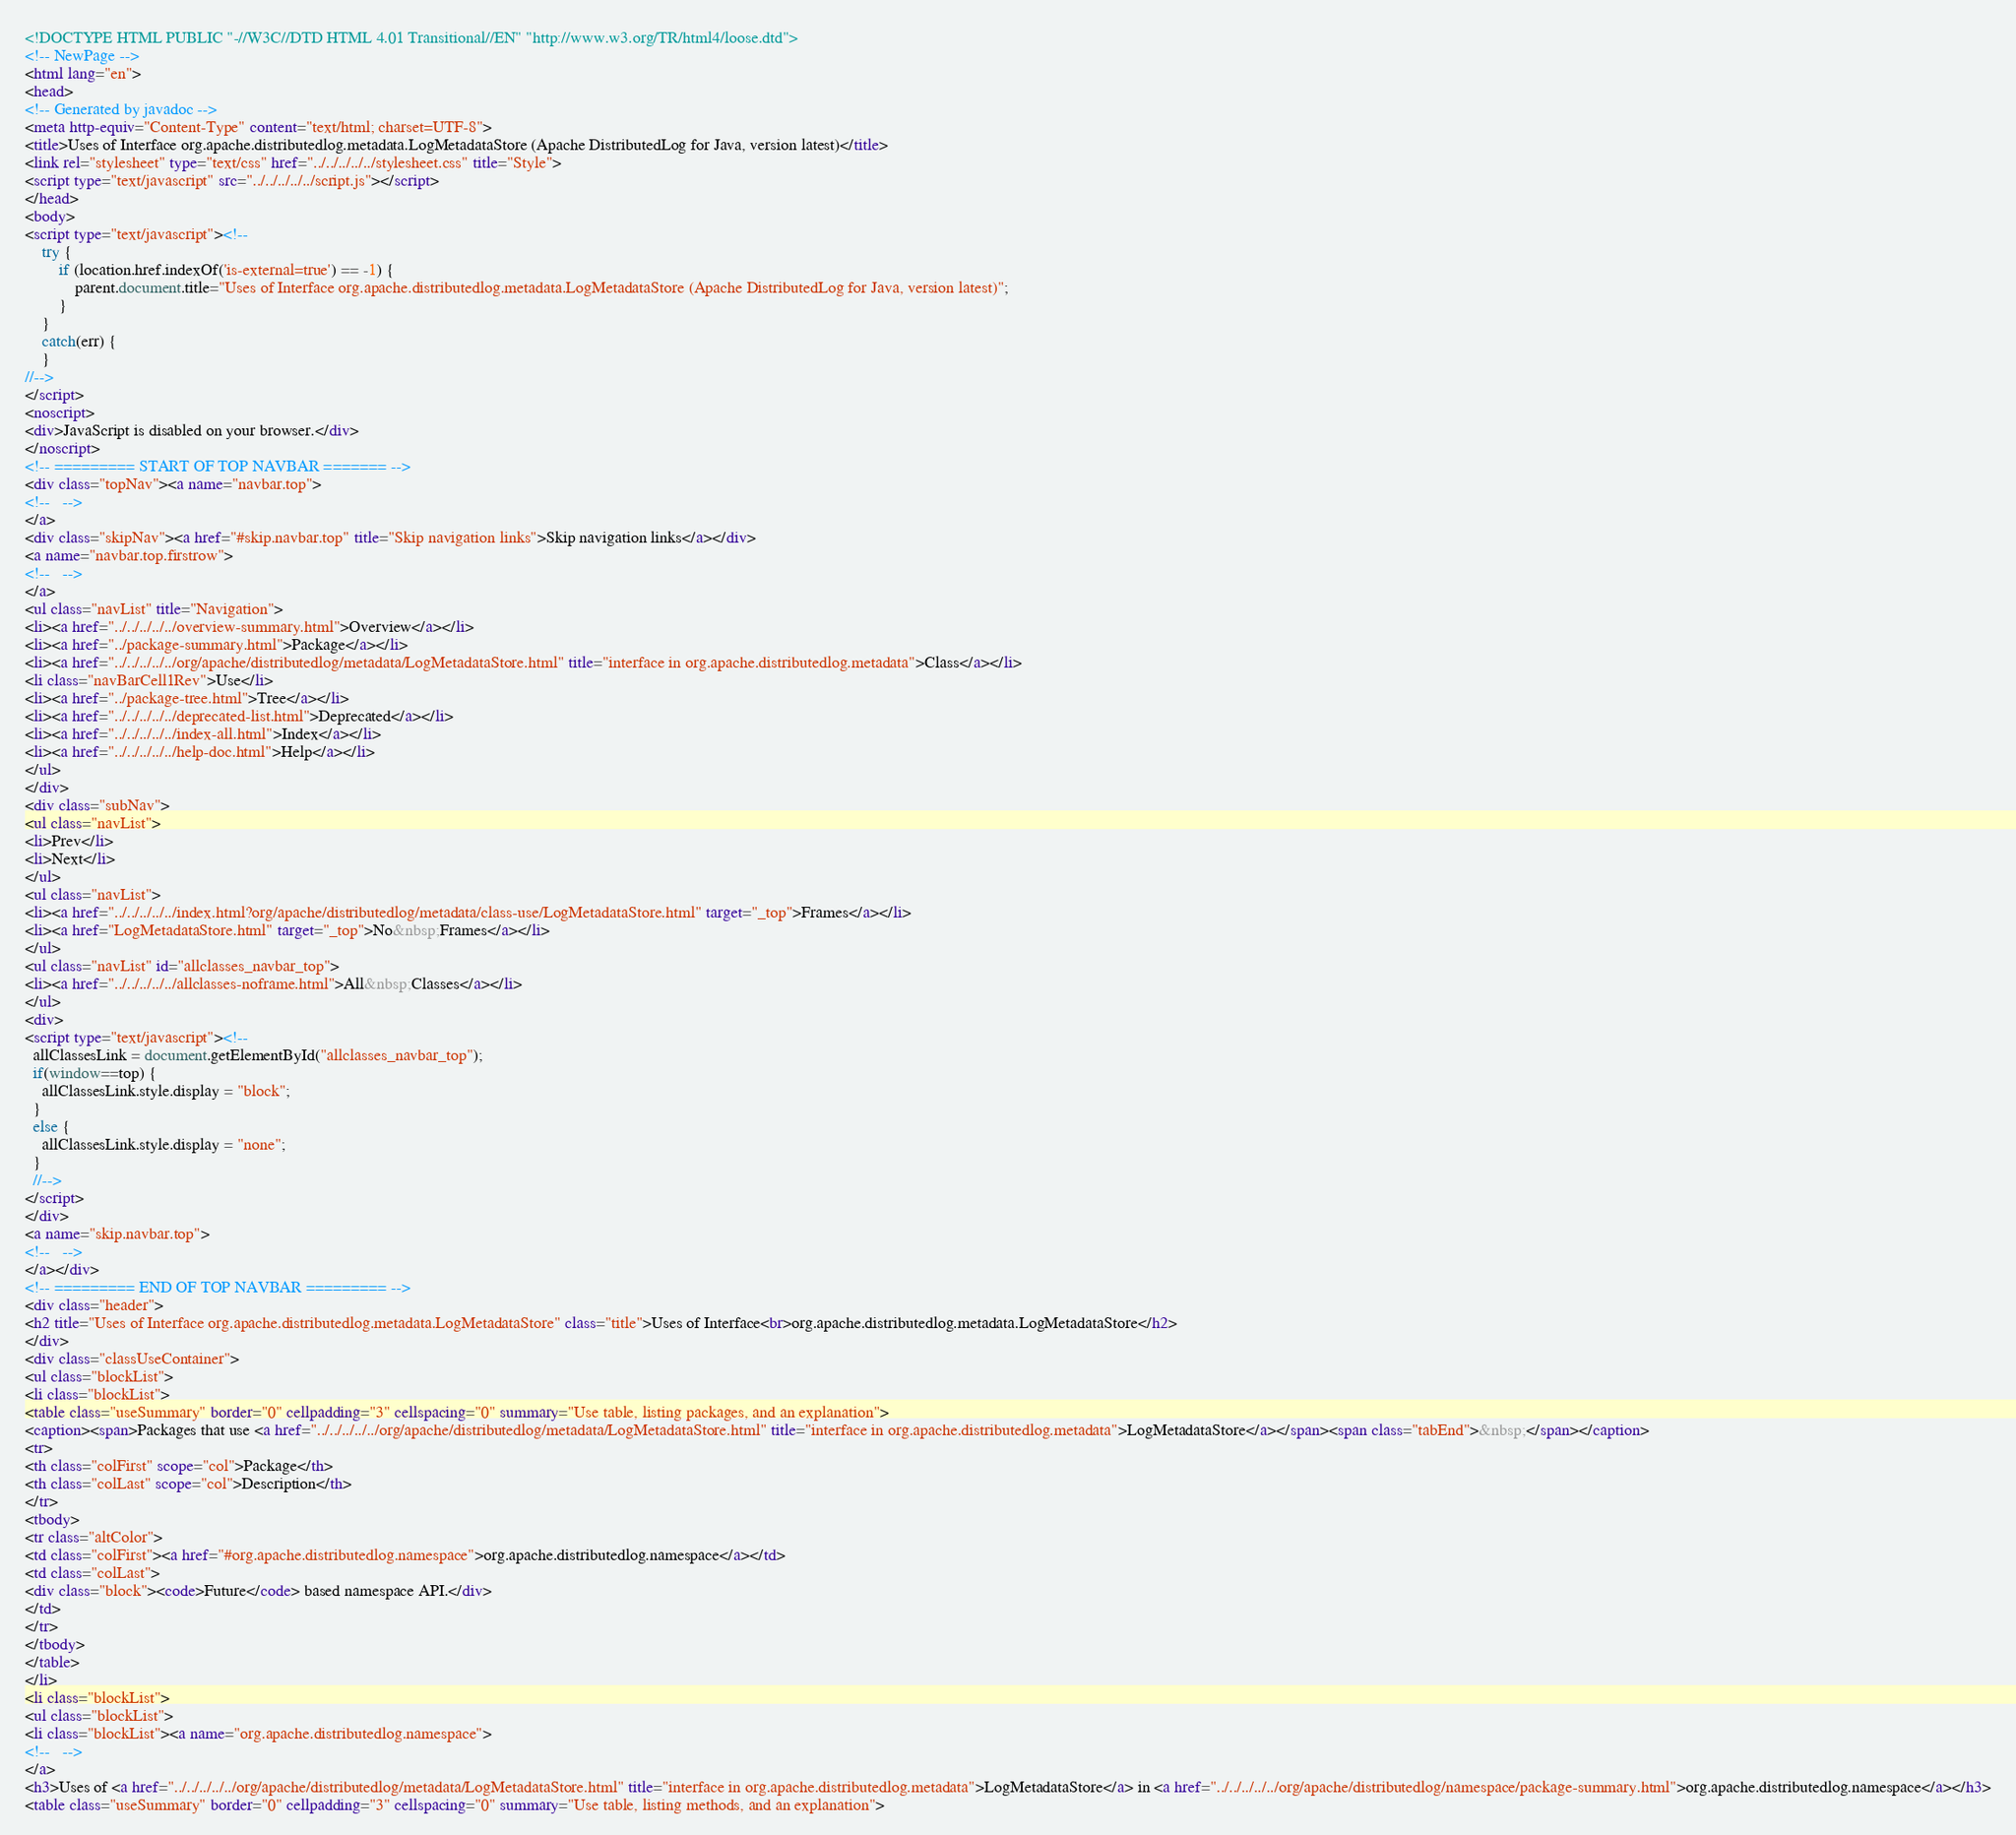<code> <loc_0><loc_0><loc_500><loc_500><_HTML_><!DOCTYPE HTML PUBLIC "-//W3C//DTD HTML 4.01 Transitional//EN" "http://www.w3.org/TR/html4/loose.dtd">
<!-- NewPage -->
<html lang="en">
<head>
<!-- Generated by javadoc -->
<meta http-equiv="Content-Type" content="text/html; charset=UTF-8">
<title>Uses of Interface org.apache.distributedlog.metadata.LogMetadataStore (Apache DistributedLog for Java, version latest)</title>
<link rel="stylesheet" type="text/css" href="../../../../../stylesheet.css" title="Style">
<script type="text/javascript" src="../../../../../script.js"></script>
</head>
<body>
<script type="text/javascript"><!--
    try {
        if (location.href.indexOf('is-external=true') == -1) {
            parent.document.title="Uses of Interface org.apache.distributedlog.metadata.LogMetadataStore (Apache DistributedLog for Java, version latest)";
        }
    }
    catch(err) {
    }
//-->
</script>
<noscript>
<div>JavaScript is disabled on your browser.</div>
</noscript>
<!-- ========= START OF TOP NAVBAR ======= -->
<div class="topNav"><a name="navbar.top">
<!--   -->
</a>
<div class="skipNav"><a href="#skip.navbar.top" title="Skip navigation links">Skip navigation links</a></div>
<a name="navbar.top.firstrow">
<!--   -->
</a>
<ul class="navList" title="Navigation">
<li><a href="../../../../../overview-summary.html">Overview</a></li>
<li><a href="../package-summary.html">Package</a></li>
<li><a href="../../../../../org/apache/distributedlog/metadata/LogMetadataStore.html" title="interface in org.apache.distributedlog.metadata">Class</a></li>
<li class="navBarCell1Rev">Use</li>
<li><a href="../package-tree.html">Tree</a></li>
<li><a href="../../../../../deprecated-list.html">Deprecated</a></li>
<li><a href="../../../../../index-all.html">Index</a></li>
<li><a href="../../../../../help-doc.html">Help</a></li>
</ul>
</div>
<div class="subNav">
<ul class="navList">
<li>Prev</li>
<li>Next</li>
</ul>
<ul class="navList">
<li><a href="../../../../../index.html?org/apache/distributedlog/metadata/class-use/LogMetadataStore.html" target="_top">Frames</a></li>
<li><a href="LogMetadataStore.html" target="_top">No&nbsp;Frames</a></li>
</ul>
<ul class="navList" id="allclasses_navbar_top">
<li><a href="../../../../../allclasses-noframe.html">All&nbsp;Classes</a></li>
</ul>
<div>
<script type="text/javascript"><!--
  allClassesLink = document.getElementById("allclasses_navbar_top");
  if(window==top) {
    allClassesLink.style.display = "block";
  }
  else {
    allClassesLink.style.display = "none";
  }
  //-->
</script>
</div>
<a name="skip.navbar.top">
<!--   -->
</a></div>
<!-- ========= END OF TOP NAVBAR ========= -->
<div class="header">
<h2 title="Uses of Interface org.apache.distributedlog.metadata.LogMetadataStore" class="title">Uses of Interface<br>org.apache.distributedlog.metadata.LogMetadataStore</h2>
</div>
<div class="classUseContainer">
<ul class="blockList">
<li class="blockList">
<table class="useSummary" border="0" cellpadding="3" cellspacing="0" summary="Use table, listing packages, and an explanation">
<caption><span>Packages that use <a href="../../../../../org/apache/distributedlog/metadata/LogMetadataStore.html" title="interface in org.apache.distributedlog.metadata">LogMetadataStore</a></span><span class="tabEnd">&nbsp;</span></caption>
<tr>
<th class="colFirst" scope="col">Package</th>
<th class="colLast" scope="col">Description</th>
</tr>
<tbody>
<tr class="altColor">
<td class="colFirst"><a href="#org.apache.distributedlog.namespace">org.apache.distributedlog.namespace</a></td>
<td class="colLast">
<div class="block"><code>Future</code> based namespace API.</div>
</td>
</tr>
</tbody>
</table>
</li>
<li class="blockList">
<ul class="blockList">
<li class="blockList"><a name="org.apache.distributedlog.namespace">
<!--   -->
</a>
<h3>Uses of <a href="../../../../../org/apache/distributedlog/metadata/LogMetadataStore.html" title="interface in org.apache.distributedlog.metadata">LogMetadataStore</a> in <a href="../../../../../org/apache/distributedlog/namespace/package-summary.html">org.apache.distributedlog.namespace</a></h3>
<table class="useSummary" border="0" cellpadding="3" cellspacing="0" summary="Use table, listing methods, and an explanation"></code> 